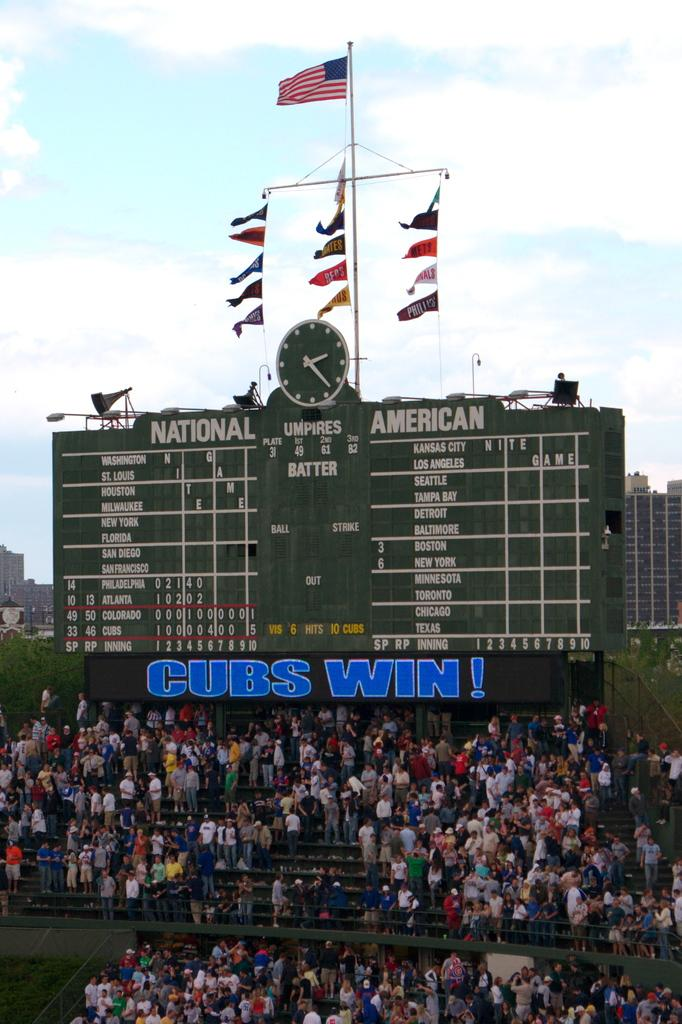<image>
Relay a brief, clear account of the picture shown. A view of the bleachers and scoreboard that reads Cubs Win! 